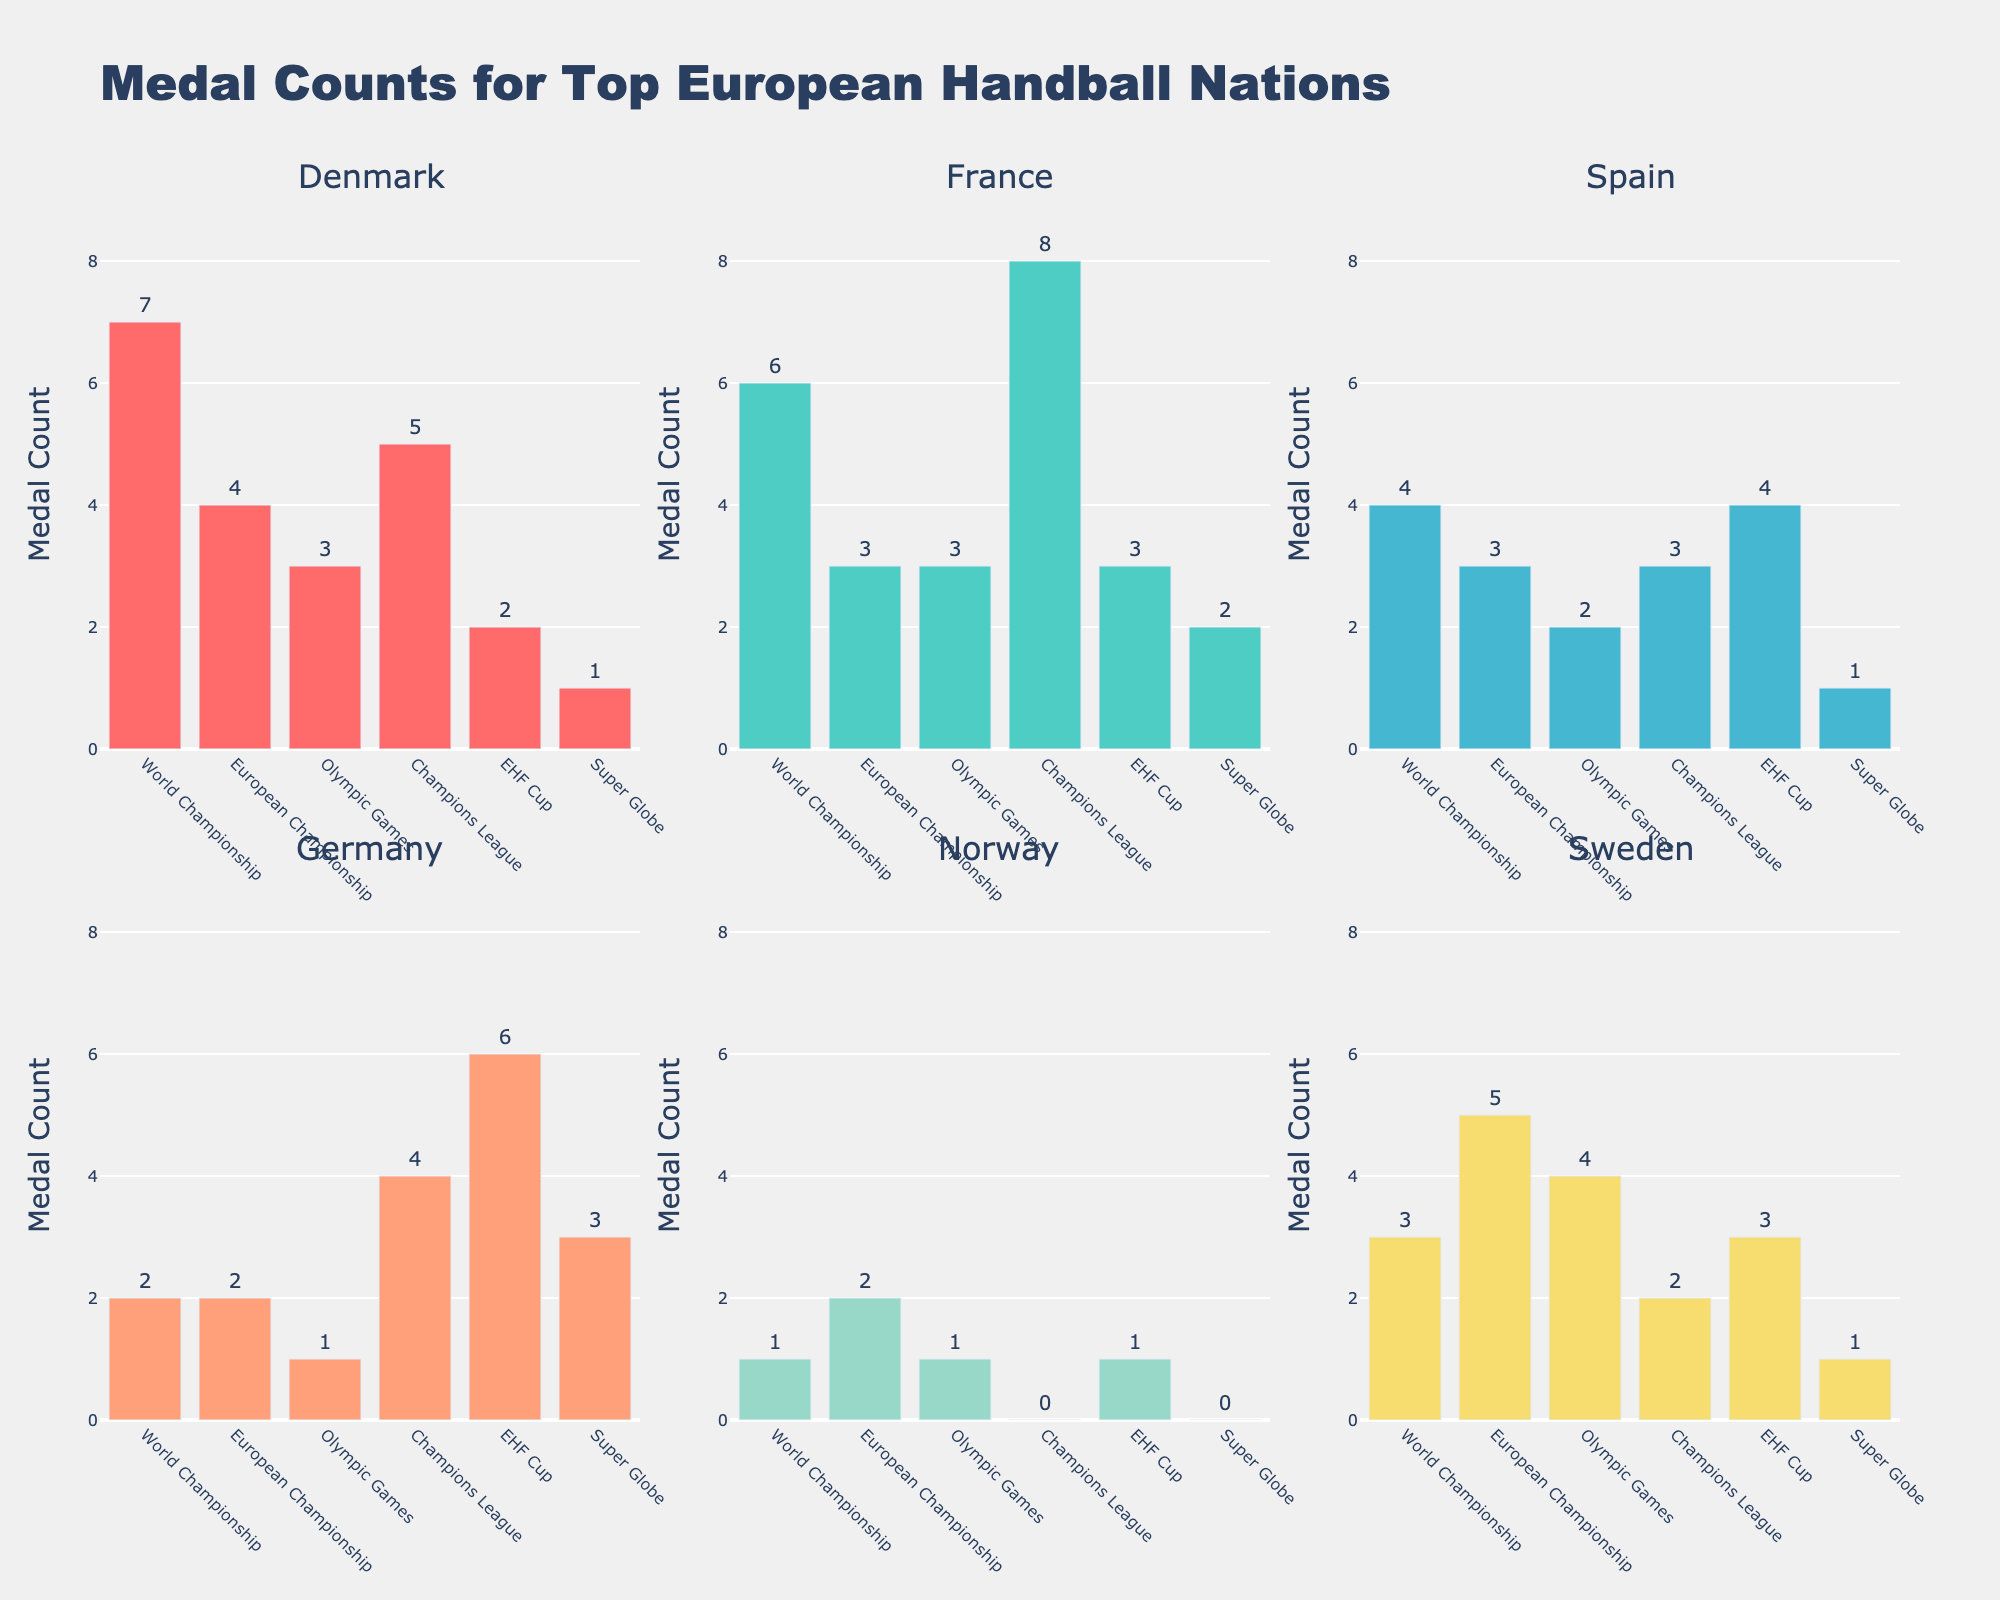How many medals has Denmark won in the World Championship? The subplot for Denmark shows the medal counts in different tournaments. Look at the World Championship bar in the Denmark subplot.
Answer: 7 Which country has won the most medals in the Champions League? Look at each subplot and compare the bars representing the Champions League medal counts. The tallest bar belongs to France.
Answer: France What is the total number of medals won by Spain across all tournaments? Sum the medal counts for Spain from each bar in its subplot: World Championship (4) + European Championship (3) + Olympic Games (2) + Champions League (3) + EHF Cup (4) + Super Globe (1).
Answer: 17 Which tournament did Sweden win the most medals in? Find the tallest bar in the Sweden subplot. The European Championship has the highest count.
Answer: European Championship How does Germany’s medal count in the EHF Cup compare to its medal count in the Champions League? Compare the heights of the bars for Germany in the EHF Cup and Champions League in the Germany subplot. Germany has 6 medals in the EHF Cup and 4 medals in the Champions League.
Answer: EHF Cup > Champions League What is the total number of medals won by Norway in the European Championship and the Olympic Games combined? Add the medal counts for Norway in the European Championship (2) and the Olympic Games (1).
Answer: 3 Which country has won the least medals in the Super Globe? Compare the heights of the bars for each country in the Super Globe category. Norway has the lowest count with 0 medals.
Answer: Norway What is the difference in medal counts between France and Sweden in the World Championship? Subtract the medal count of Sweden in the World Championship (3) from that of France (6).
Answer: 3 How many more medals has Denmark won in the European Championship compared to the Olympic Games? Subtract the number of Olympic Games medals (3) from the number of European Championship medals (4).
Answer: 1 Which tournament has Germany won the most medals in? Identify the tallest bar in the Germany subplot, which is the EHF Cup.
Answer: EHF Cup 